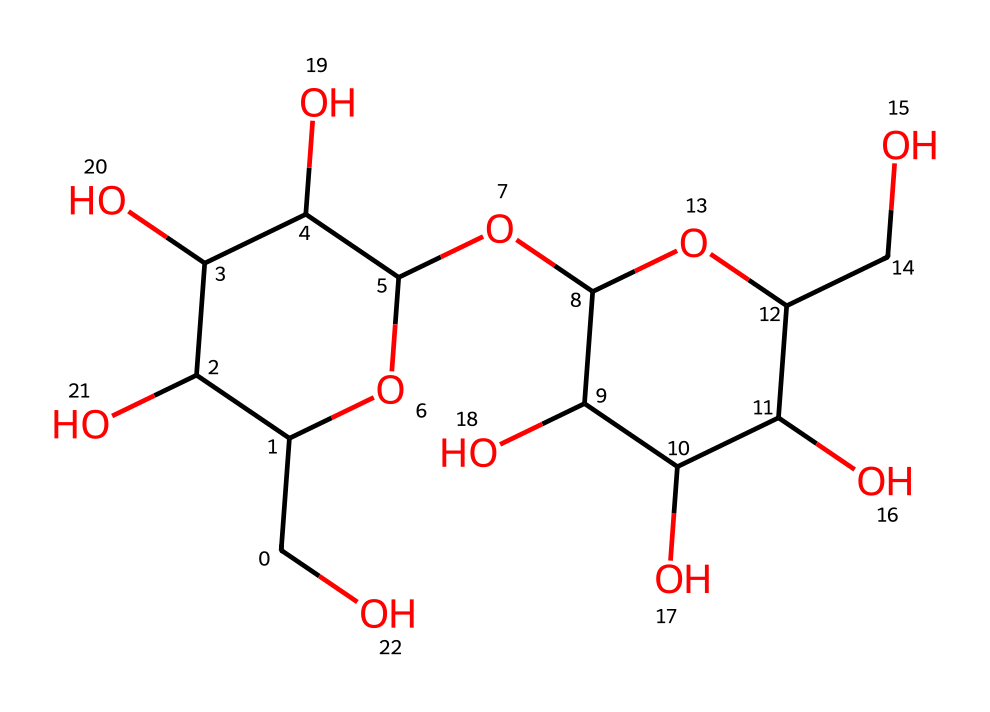What is the molecular formula of this compound? To derive the molecular formula, count the number of each type of atom present in the SMILES representation. There are 24 carbon (C) atoms, 42 hydrogen (H) atoms, and 22 oxygen (O) atoms. So, the molecular formula is C24H42O22.
Answer: C24H42O22 How many hydroxyl (–OH) groups are present? A hydroxyl group can be identified by the presence of an oxygen atom (O) directly bonded to a hydrogen atom (H). By analyzing the structure, there are multiple instances of –OH groups visible. Counting them gives us a total of 8 hydroxyl groups.
Answer: 8 What type of carbohydrate is represented by this structure? The structure shown represents glycogen, which is a polysaccharide. It's specifically a storage form of glucose in animals. The branched structure is characteristic of glycogen, differentiating it from other carbohydrates.
Answer: polysaccharide How many rings are present in this molecule? The structure includes two cyclic components, each corresponding to a ring structure in the glucose units. Analyzing the representation reveals that there are 2 distinct rings present in the chemical structure.
Answer: 2 Is this chemical hydrophilic or hydrophobic? The presence of multiple hydroxyl groups (–OH) in the structure makes this molecule hydrophilic, as these groups can form hydrogen bonds with water. Therefore, this carbohydrate is water-soluble and favors interactions with aqueous environments.
Answer: hydrophilic What is the primary function of glycogen in muscles during high-stress situations? Glycogen serves as an energy reserve in muscles, especially during high-stress situations or exercise. It is broken down into glucose to provide immediate energy to meet the increased metabolic demands of the muscles.
Answer: energy reserve 